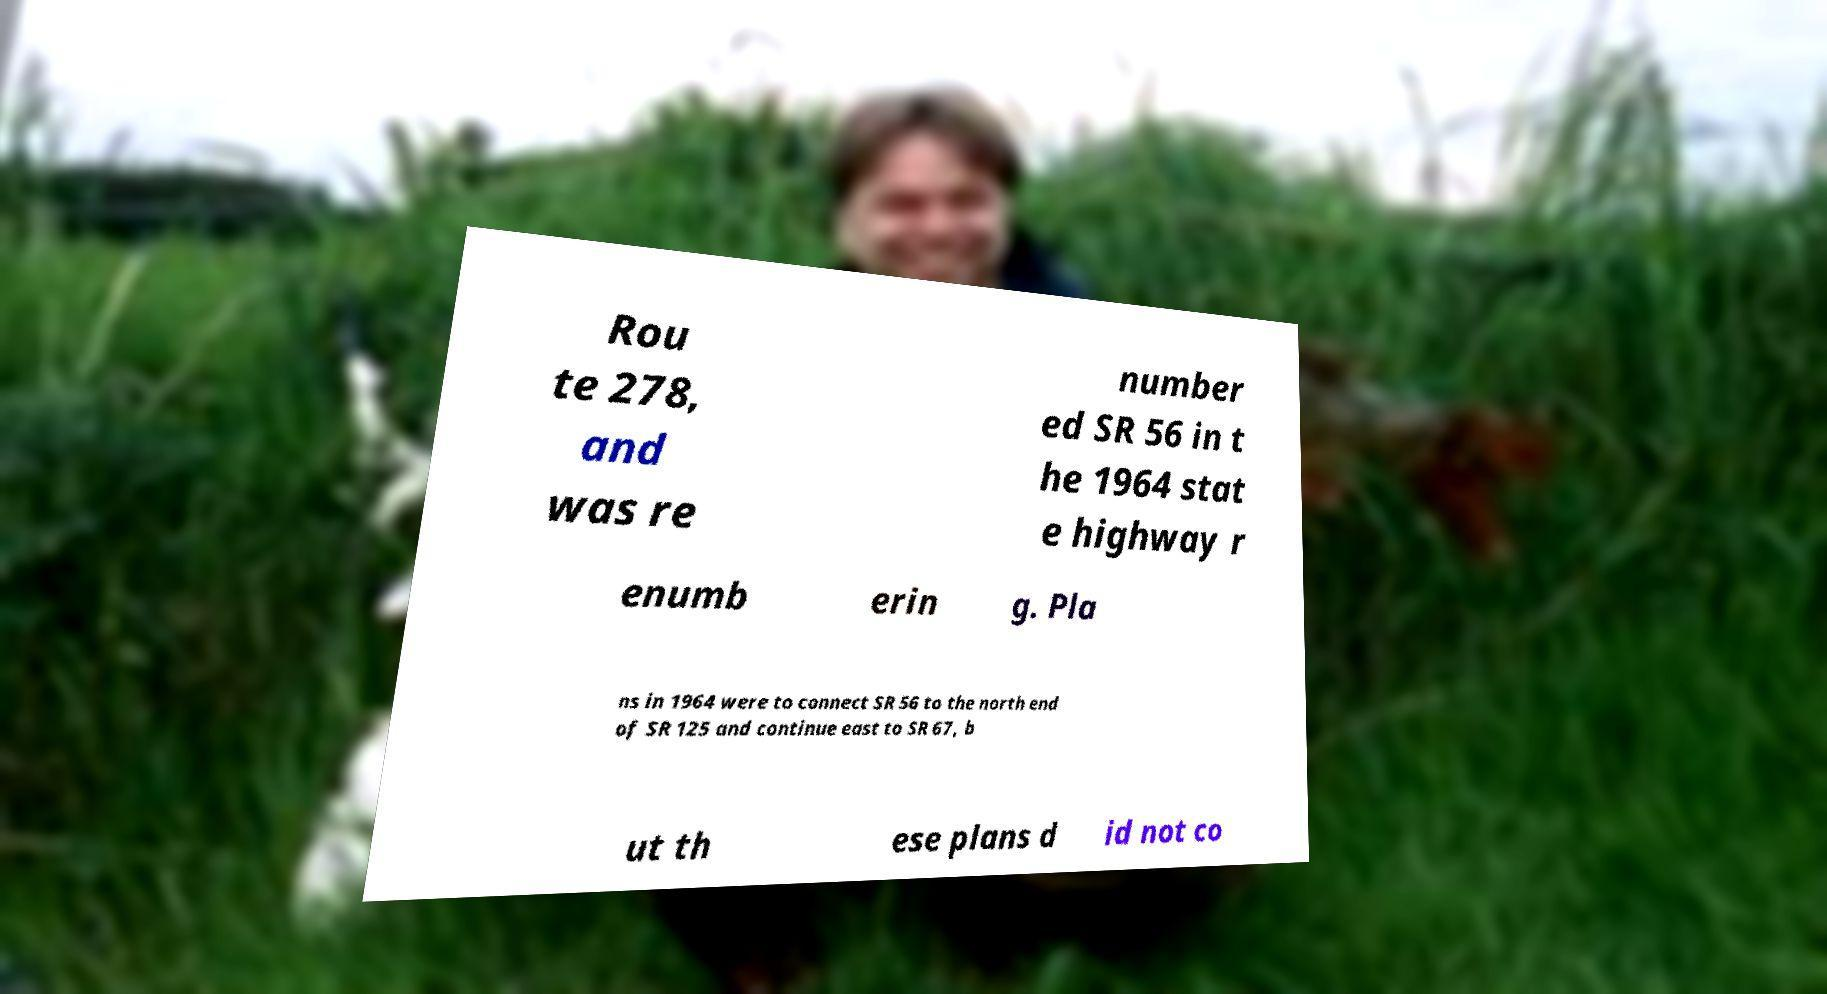For documentation purposes, I need the text within this image transcribed. Could you provide that? Rou te 278, and was re number ed SR 56 in t he 1964 stat e highway r enumb erin g. Pla ns in 1964 were to connect SR 56 to the north end of SR 125 and continue east to SR 67, b ut th ese plans d id not co 